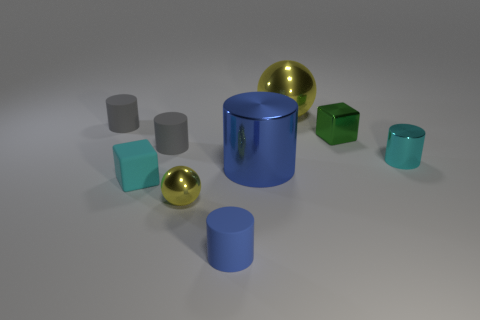What shape is the large yellow object that is the same material as the small green object?
Give a very brief answer. Sphere. What number of big objects are cylinders or yellow shiny things?
Provide a succinct answer. 2. What number of other things are the same color as the big shiny ball?
Keep it short and to the point. 1. What number of cyan cubes are to the right of the tiny gray cylinder right of the tiny gray matte object that is behind the green cube?
Give a very brief answer. 0. There is a sphere that is in front of the cyan rubber object; is it the same size as the big ball?
Provide a short and direct response. No. Are there fewer small metallic spheres that are behind the small yellow metallic thing than matte objects in front of the metal cube?
Keep it short and to the point. Yes. Is the rubber cube the same color as the small metallic cylinder?
Offer a very short reply. Yes. Are there fewer big blue cylinders that are to the right of the tiny cyan rubber thing than tiny matte things?
Offer a very short reply. Yes. What material is the tiny object that is the same color as the rubber block?
Ensure brevity in your answer.  Metal. Is the cyan cube made of the same material as the cyan cylinder?
Provide a succinct answer. No. 